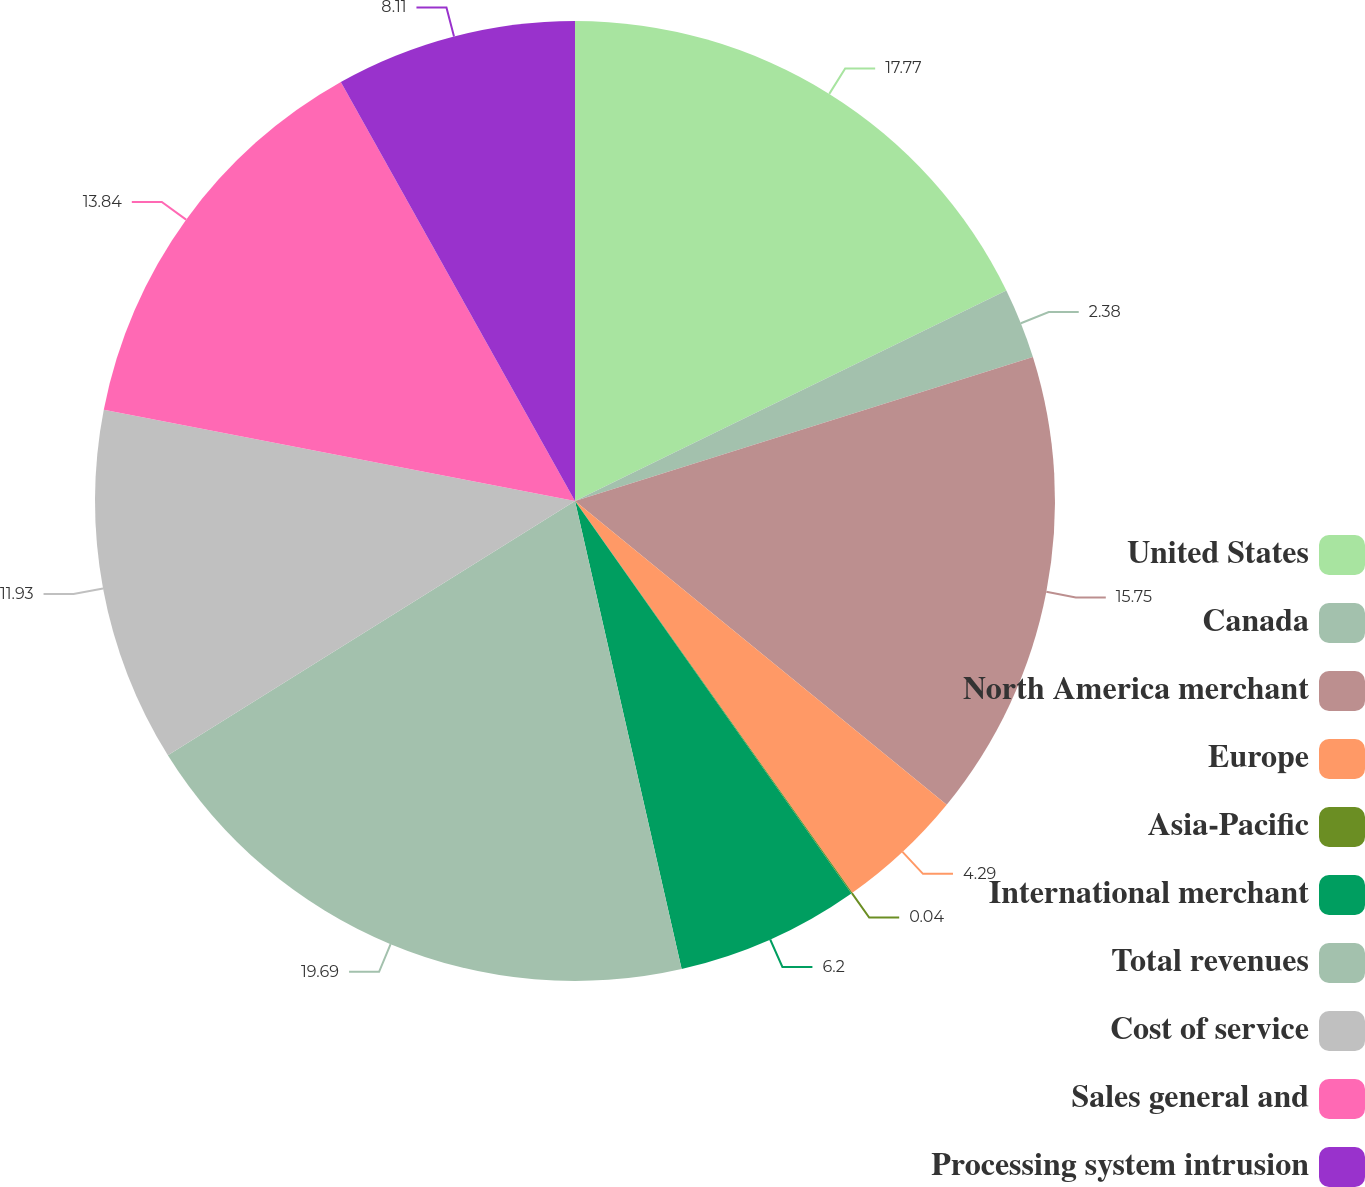Convert chart. <chart><loc_0><loc_0><loc_500><loc_500><pie_chart><fcel>United States<fcel>Canada<fcel>North America merchant<fcel>Europe<fcel>Asia-Pacific<fcel>International merchant<fcel>Total revenues<fcel>Cost of service<fcel>Sales general and<fcel>Processing system intrusion<nl><fcel>17.77%<fcel>2.38%<fcel>15.75%<fcel>4.29%<fcel>0.04%<fcel>6.2%<fcel>19.68%<fcel>11.93%<fcel>13.84%<fcel>8.11%<nl></chart> 